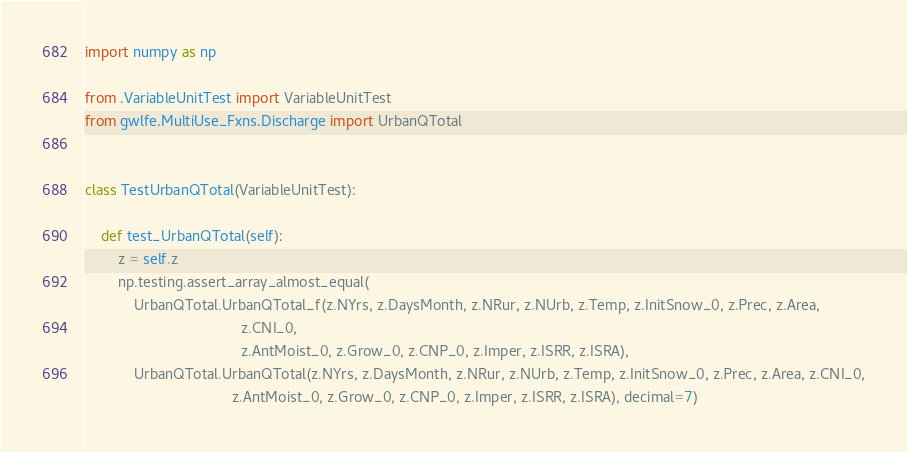Convert code to text. <code><loc_0><loc_0><loc_500><loc_500><_Python_>import numpy as np

from .VariableUnitTest import VariableUnitTest
from gwlfe.MultiUse_Fxns.Discharge import UrbanQTotal


class TestUrbanQTotal(VariableUnitTest):

    def test_UrbanQTotal(self):
        z = self.z
        np.testing.assert_array_almost_equal(
            UrbanQTotal.UrbanQTotal_f(z.NYrs, z.DaysMonth, z.NRur, z.NUrb, z.Temp, z.InitSnow_0, z.Prec, z.Area,
                                      z.CNI_0,
                                      z.AntMoist_0, z.Grow_0, z.CNP_0, z.Imper, z.ISRR, z.ISRA),
            UrbanQTotal.UrbanQTotal(z.NYrs, z.DaysMonth, z.NRur, z.NUrb, z.Temp, z.InitSnow_0, z.Prec, z.Area, z.CNI_0,
                                    z.AntMoist_0, z.Grow_0, z.CNP_0, z.Imper, z.ISRR, z.ISRA), decimal=7)
</code> 